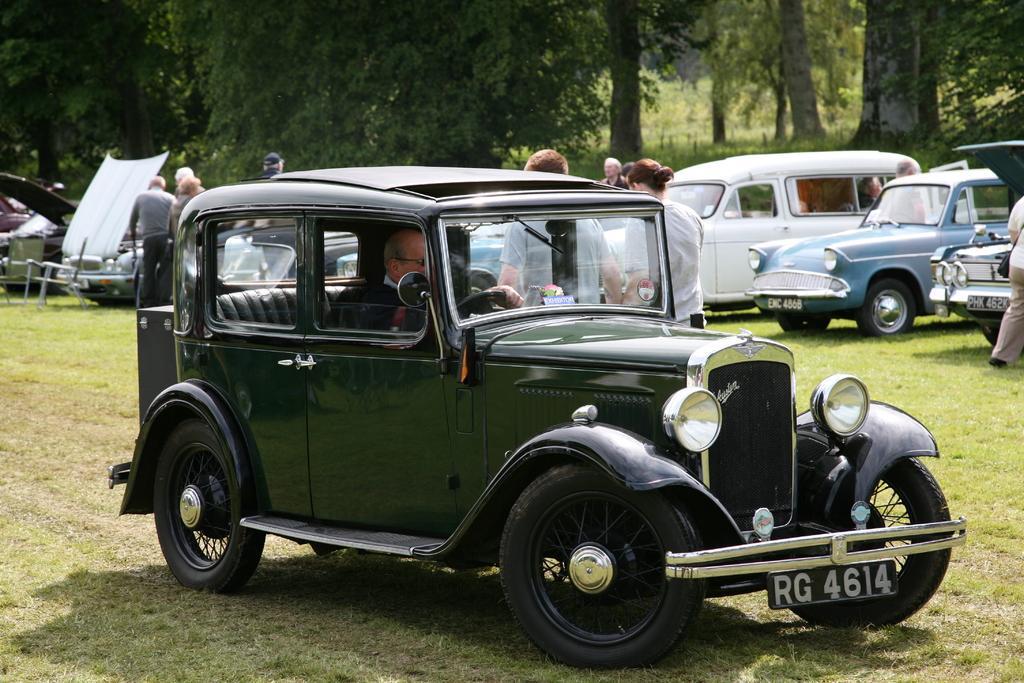In one or two sentences, can you explain what this image depicts? In this image I can see an open grass ground and on it I can see few vehicles and I can see few people are standing. I can also see one man is sitting in this vehicle and in the background I can see number of trees. 